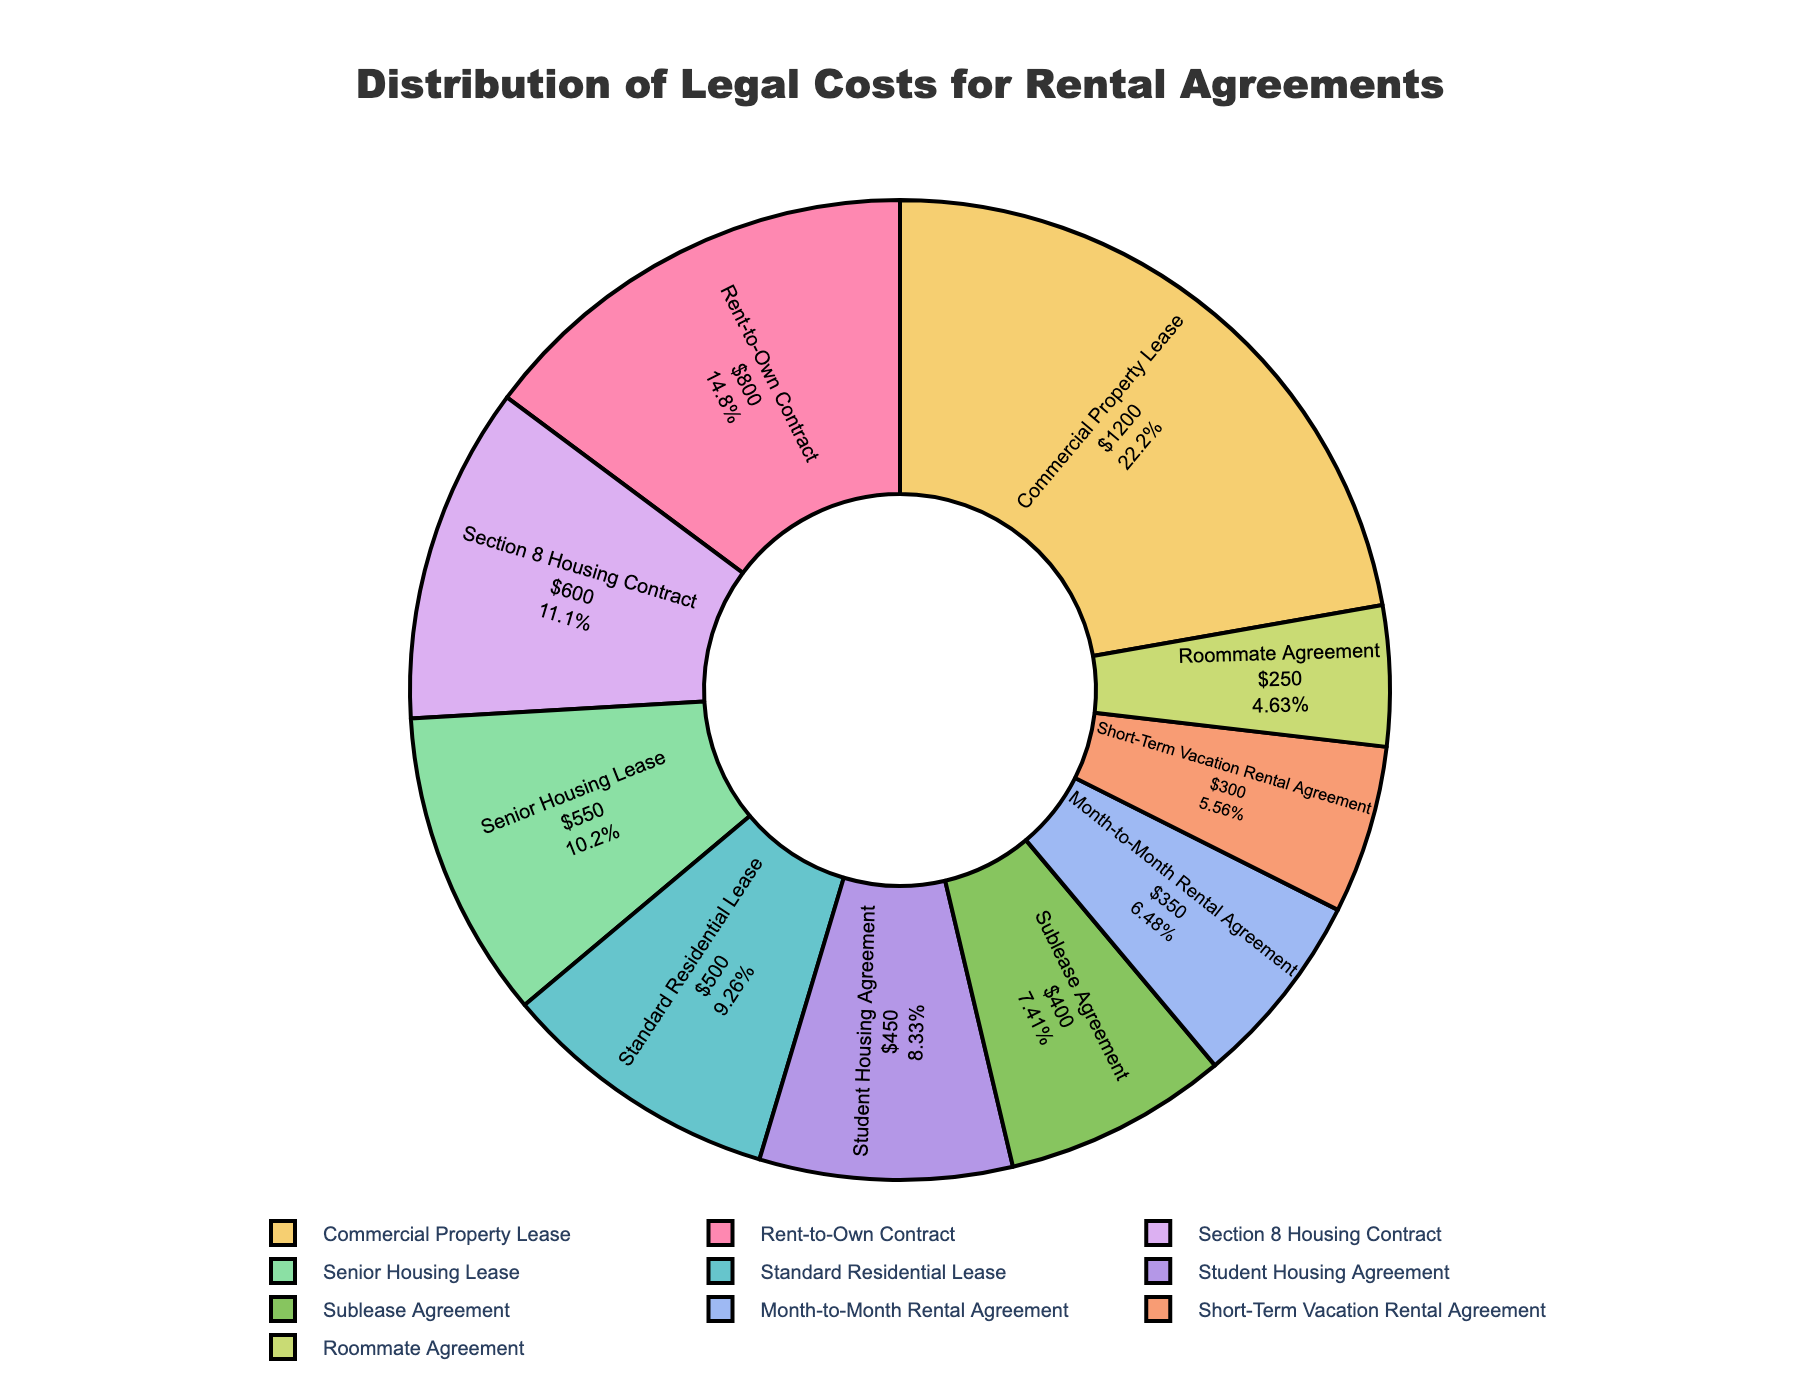Which type of rental agreement accounts for the largest portion of legal costs? The pie chart shows that the "Commercial Property Lease" segment is the largest slice, indicating it has the highest legal costs among all types of rental agreements.
Answer: Commercial Property Lease What is the proportion of legal costs associated with Standard Residential Leases in the overall distribution? The pie chart indicates specific percentages for each type of agreement. The "Standard Residential Lease" is recorded at 8%.
Answer: 8% How does the legal cost of the Rent-to-Own Contract compare to the Senior Housing Lease? By looking at the pie slices, we see that the "Rent-to-Own Contract" has a larger segment than the "Senior Housing Lease". Rent-to-Own Contract has $800 while Senior Housing Lease has $550.
Answer: Rent-to-Own Contract has higher legal cost What is the combined legal cost of the Roommate Agreement and Student Housing Agreement? Adding the legal costs of the two agreements: $250 (Roommate Agreement) + $450 (Student Housing Agreement) gives us the combined cost.
Answer: $700 Which type of rental agreement has a legal cost closest to $400? The pie chart shows the legal costs next to each slice. "Sublease Agreement" has a legal cost of $400, which is the closest to that amount.
Answer: Sublease Agreement What is the difference in legal cost between the highest and lowest cost agreements? The highest legal cost is for "Commercial Property Lease" at $1200 and the lowest cost is for "Roommate Agreement" at $250. The difference is $1200 - $250.
Answer: $950 Which rental agreements combined make up more than 50% of the total legal costs? By adding the percentages: Commercial Property Lease (24%), Rent-to-Own Contract (16%), Section 8 Housing Contract (12%), Senior Housing Lease (11%) and Standard Residential Lease (8%) gives a total more than 50%.
Answer: Commercial Property Lease, Rent-to-Own Contract, Section 8 Housing Contract, Senior Housing Lease, Standard Residential Lease Identify the agreements that contribute under 10% of legal costs each. Visual inspection of the pie chart shows that "Short-Term Vacation Rental Agreement," "Sublease Agreement," "Month-to-Month Rental Agreement," "Roommate Agreement," and "Student Housing Agreement" each constitute less than 10%.
Answer: Short-Term Vacation Rental Agreement, Sublease Agreement, Month-to-Month Rental Agreement, Roommate Agreement, Student Housing Agreement 